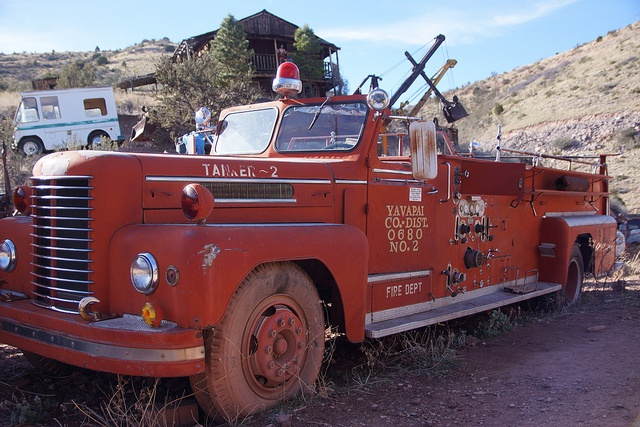Describe the objects in this image and their specific colors. I can see truck in lightblue, maroon, brown, black, and purple tones, truck in lightblue, darkgray, lavender, and black tones, and people in lightblue, gray, black, purple, and maroon tones in this image. 